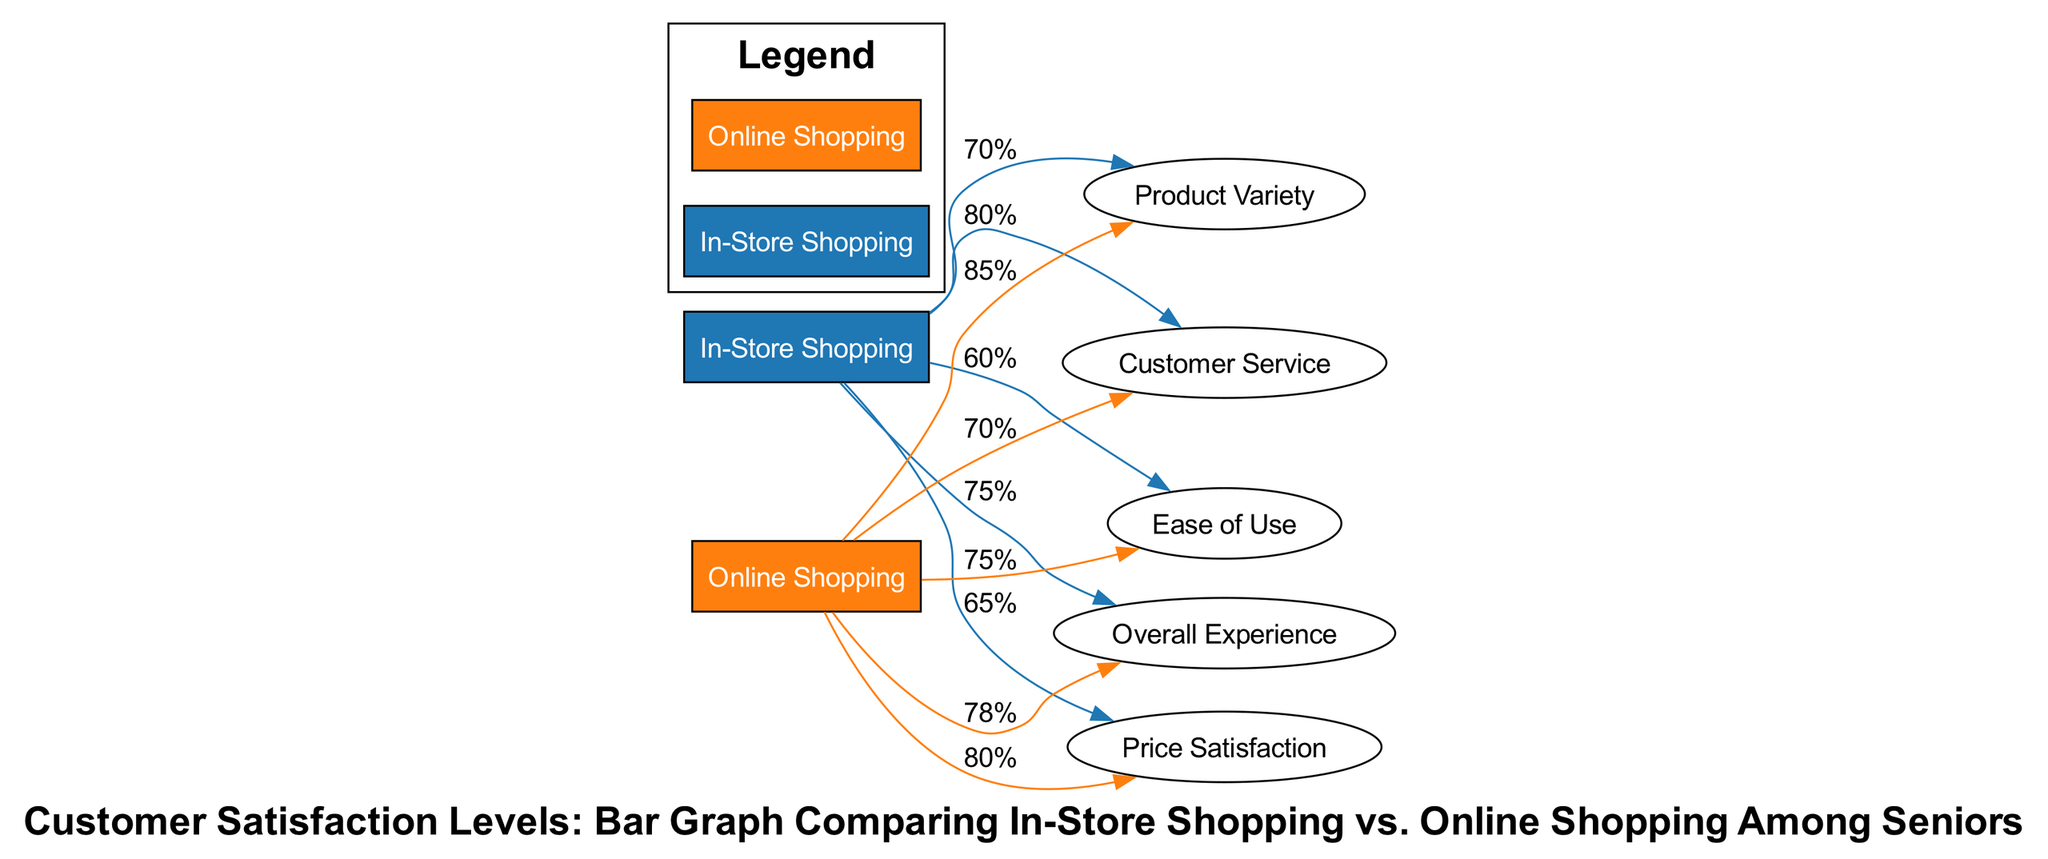What is the satisfaction level for Product Variety in In-Store Shopping? The diagram shows a bar for In-Store Shopping under Product Variety with a value of 70%.
Answer: 70% What is the overall satisfaction level for Online Shopping? The diagram indicates that the Overall Experience satisfaction level for Online Shopping is 78%.
Answer: 78% Which type of shopping has a higher satisfaction level for Ease of Use? Comparing the values of Ease of Use, Online Shopping has 75% while In-Store Shopping has 60%, making Online Shopping higher.
Answer: Online Shopping What is the satisfaction level difference for Price Satisfaction between In-Store and Online Shopping? The satisfaction level for Price Satisfaction in In-Store Shopping is 65% and for Online Shopping is 80%. The difference is calculated as 80% - 65%, resulting in 15%.
Answer: 15% Which category has the lowest satisfaction level in In-Store Shopping? Looking at all the categories for In-Store Shopping, Ease of Use at 60% has the lowest value compared to the others.
Answer: Ease of Use What is the highest satisfaction level category in Online Shopping? In the Online Shopping section, Product Variety has the highest satisfaction level at 85%.
Answer: Product Variety How many satisfaction categories are compared in the diagram? The diagram contains five satisfaction categories: Product Variety, Ease of Use, Customer Service, Price Satisfaction, Overall Experience, counting a total of five.
Answer: Five Which shopping method has higher Customer Service satisfaction? The Customer Service level for In-Store Shopping is 80% and for Online Shopping it's 70%, thus In-Store Shopping has a higher level.
Answer: In-Store Shopping What overall experience satisfaction level is reported for In-Store Shopping? The diagram shows the Overall Experience satisfaction level for In-Store Shopping as 75%.
Answer: 75% 